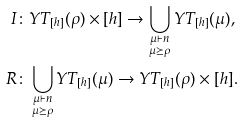<formula> <loc_0><loc_0><loc_500><loc_500>I & \colon Y T _ { [ h ] } ( \rho ) \times [ h ] \to \bigcup _ { \substack { \mu \vdash n \\ \mu \succeq \rho } } Y T _ { [ h ] } ( \mu ) , \\ R & \colon \bigcup _ { \substack { \mu \vdash n \\ \mu \succeq \rho } } Y T _ { [ h ] } ( \mu ) \to Y T _ { [ h ] } ( \rho ) \times [ h ] .</formula> 